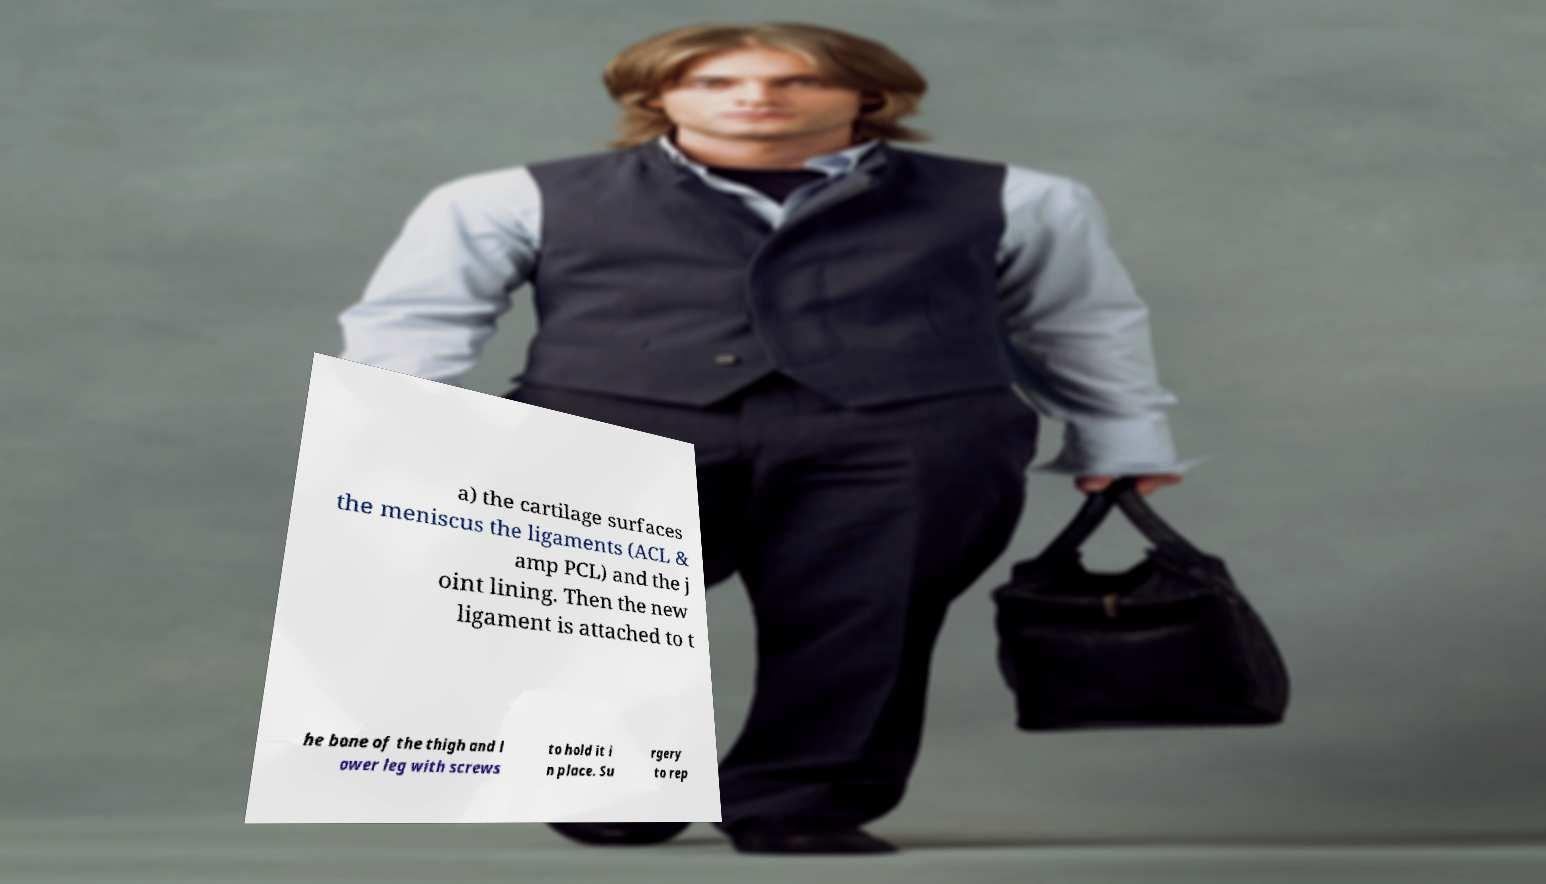Please identify and transcribe the text found in this image. a) the cartilage surfaces the meniscus the ligaments (ACL & amp PCL) and the j oint lining. Then the new ligament is attached to t he bone of the thigh and l ower leg with screws to hold it i n place. Su rgery to rep 